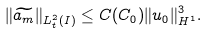<formula> <loc_0><loc_0><loc_500><loc_500>\| \widetilde { a _ { m } } \| _ { L ^ { 2 } _ { t } ( I ) } \leq C ( C _ { 0 } ) \| u _ { 0 } \| _ { H ^ { 1 } } ^ { 3 } .</formula> 